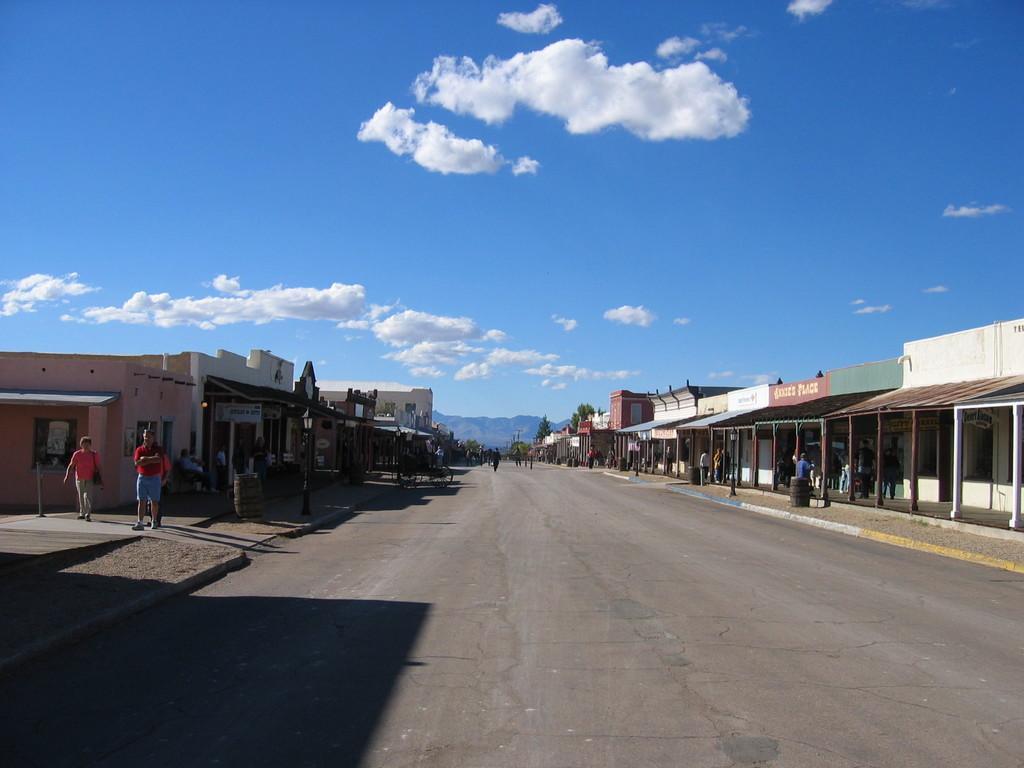Could you give a brief overview of what you see in this image? In this picture I can see few buildings and trees and few people walking and I can see hill and a blue cloudy sky. 